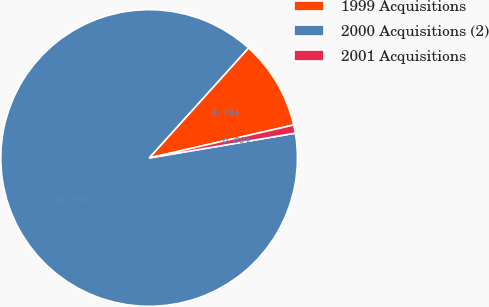<chart> <loc_0><loc_0><loc_500><loc_500><pie_chart><fcel>1999 Acquisitions<fcel>2000 Acquisitions (2)<fcel>2001 Acquisitions<nl><fcel>9.74%<fcel>89.37%<fcel>0.89%<nl></chart> 